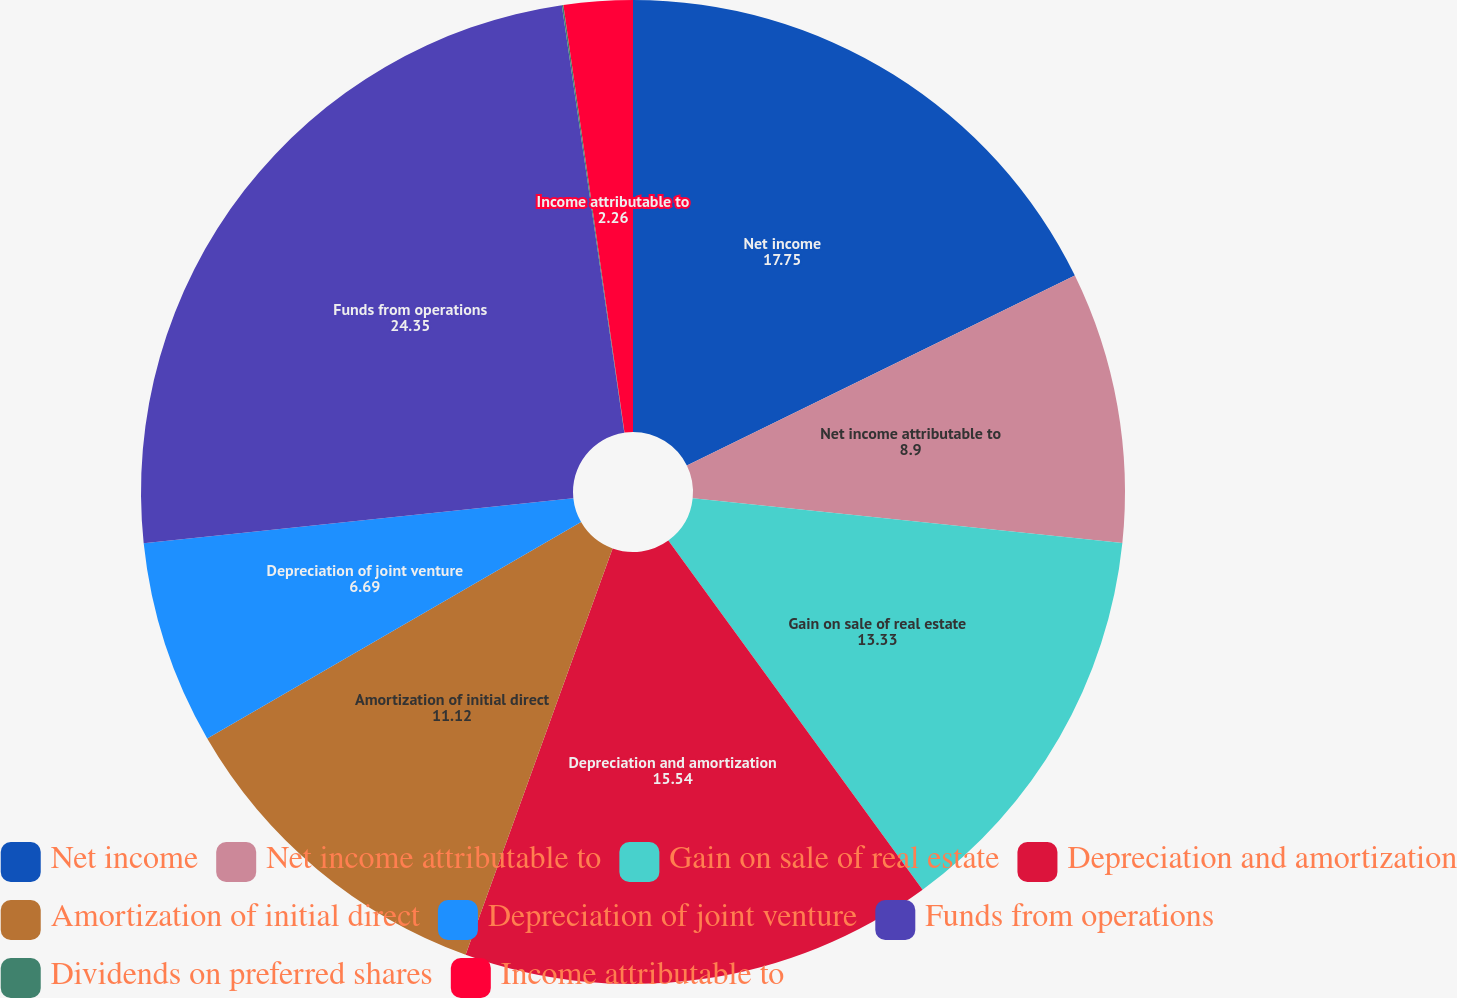<chart> <loc_0><loc_0><loc_500><loc_500><pie_chart><fcel>Net income<fcel>Net income attributable to<fcel>Gain on sale of real estate<fcel>Depreciation and amortization<fcel>Amortization of initial direct<fcel>Depreciation of joint venture<fcel>Funds from operations<fcel>Dividends on preferred shares<fcel>Income attributable to<nl><fcel>17.75%<fcel>8.9%<fcel>13.33%<fcel>15.54%<fcel>11.12%<fcel>6.69%<fcel>24.35%<fcel>0.05%<fcel>2.26%<nl></chart> 